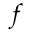Convert formula to latex. <formula><loc_0><loc_0><loc_500><loc_500>f</formula> 